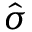Convert formula to latex. <formula><loc_0><loc_0><loc_500><loc_500>\hat { \sigma }</formula> 